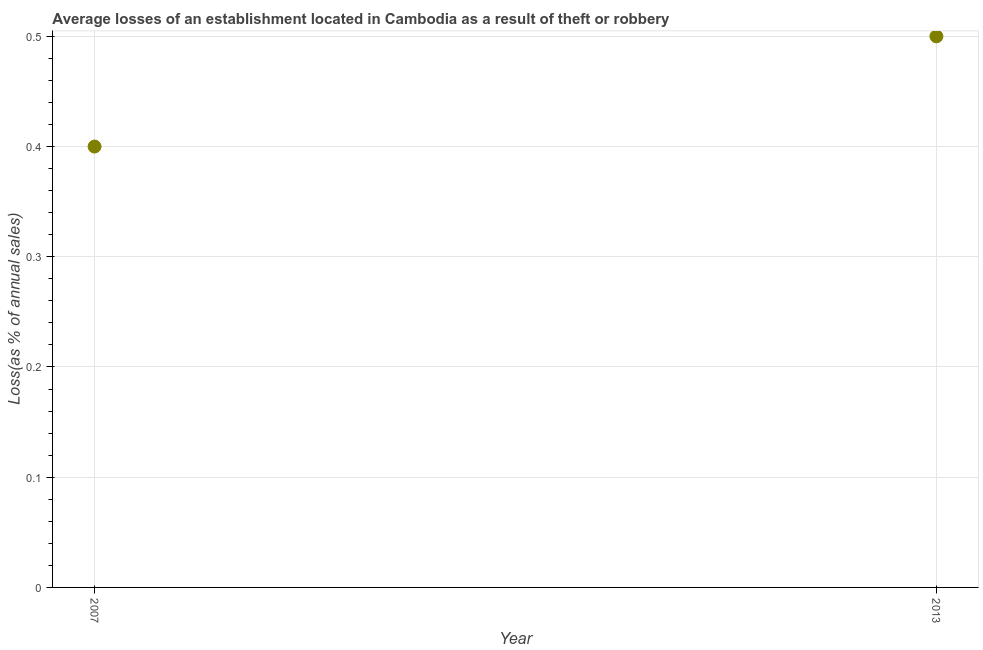Across all years, what is the minimum losses due to theft?
Your answer should be compact. 0.4. In which year was the losses due to theft maximum?
Ensure brevity in your answer.  2013. In which year was the losses due to theft minimum?
Offer a terse response. 2007. What is the difference between the losses due to theft in 2007 and 2013?
Your answer should be very brief. -0.1. What is the average losses due to theft per year?
Provide a short and direct response. 0.45. What is the median losses due to theft?
Keep it short and to the point. 0.45. In how many years, is the losses due to theft greater than 0.18 %?
Your answer should be compact. 2. Do a majority of the years between 2013 and 2007 (inclusive) have losses due to theft greater than 0.46 %?
Make the answer very short. No. What is the ratio of the losses due to theft in 2007 to that in 2013?
Your answer should be very brief. 0.8. In how many years, is the losses due to theft greater than the average losses due to theft taken over all years?
Your answer should be compact. 1. Does the losses due to theft monotonically increase over the years?
Provide a short and direct response. Yes. How many years are there in the graph?
Your answer should be compact. 2. Are the values on the major ticks of Y-axis written in scientific E-notation?
Offer a very short reply. No. What is the title of the graph?
Provide a succinct answer. Average losses of an establishment located in Cambodia as a result of theft or robbery. What is the label or title of the X-axis?
Offer a very short reply. Year. What is the label or title of the Y-axis?
Your answer should be very brief. Loss(as % of annual sales). What is the ratio of the Loss(as % of annual sales) in 2007 to that in 2013?
Your answer should be compact. 0.8. 